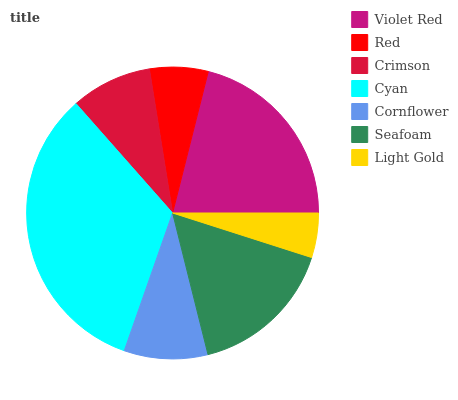Is Light Gold the minimum?
Answer yes or no. Yes. Is Cyan the maximum?
Answer yes or no. Yes. Is Red the minimum?
Answer yes or no. No. Is Red the maximum?
Answer yes or no. No. Is Violet Red greater than Red?
Answer yes or no. Yes. Is Red less than Violet Red?
Answer yes or no. Yes. Is Red greater than Violet Red?
Answer yes or no. No. Is Violet Red less than Red?
Answer yes or no. No. Is Cornflower the high median?
Answer yes or no. Yes. Is Cornflower the low median?
Answer yes or no. Yes. Is Light Gold the high median?
Answer yes or no. No. Is Violet Red the low median?
Answer yes or no. No. 